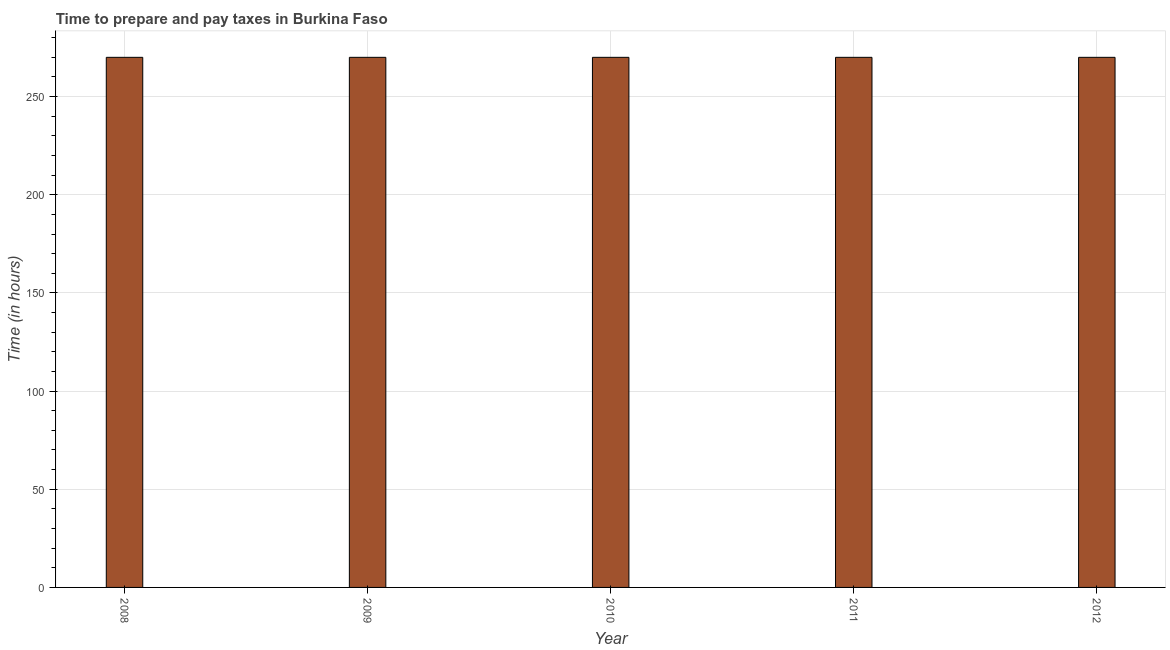What is the title of the graph?
Keep it short and to the point. Time to prepare and pay taxes in Burkina Faso. What is the label or title of the Y-axis?
Your response must be concise. Time (in hours). What is the time to prepare and pay taxes in 2009?
Keep it short and to the point. 270. Across all years, what is the maximum time to prepare and pay taxes?
Your response must be concise. 270. Across all years, what is the minimum time to prepare and pay taxes?
Offer a terse response. 270. In which year was the time to prepare and pay taxes maximum?
Offer a very short reply. 2008. In which year was the time to prepare and pay taxes minimum?
Offer a very short reply. 2008. What is the sum of the time to prepare and pay taxes?
Provide a succinct answer. 1350. What is the difference between the time to prepare and pay taxes in 2010 and 2012?
Offer a very short reply. 0. What is the average time to prepare and pay taxes per year?
Your answer should be very brief. 270. What is the median time to prepare and pay taxes?
Offer a terse response. 270. What is the ratio of the time to prepare and pay taxes in 2008 to that in 2010?
Offer a very short reply. 1. What is the difference between the highest and the second highest time to prepare and pay taxes?
Provide a succinct answer. 0. How many bars are there?
Give a very brief answer. 5. How many years are there in the graph?
Keep it short and to the point. 5. What is the difference between two consecutive major ticks on the Y-axis?
Make the answer very short. 50. What is the Time (in hours) of 2008?
Provide a short and direct response. 270. What is the Time (in hours) of 2009?
Your response must be concise. 270. What is the Time (in hours) in 2010?
Keep it short and to the point. 270. What is the Time (in hours) in 2011?
Provide a short and direct response. 270. What is the Time (in hours) of 2012?
Your answer should be very brief. 270. What is the difference between the Time (in hours) in 2008 and 2010?
Provide a short and direct response. 0. What is the difference between the Time (in hours) in 2008 and 2012?
Give a very brief answer. 0. What is the difference between the Time (in hours) in 2009 and 2011?
Offer a very short reply. 0. What is the difference between the Time (in hours) in 2009 and 2012?
Your answer should be compact. 0. What is the difference between the Time (in hours) in 2010 and 2012?
Provide a succinct answer. 0. What is the difference between the Time (in hours) in 2011 and 2012?
Your answer should be very brief. 0. What is the ratio of the Time (in hours) in 2008 to that in 2009?
Ensure brevity in your answer.  1. What is the ratio of the Time (in hours) in 2008 to that in 2012?
Make the answer very short. 1. What is the ratio of the Time (in hours) in 2009 to that in 2011?
Ensure brevity in your answer.  1. What is the ratio of the Time (in hours) in 2010 to that in 2011?
Your answer should be compact. 1. 